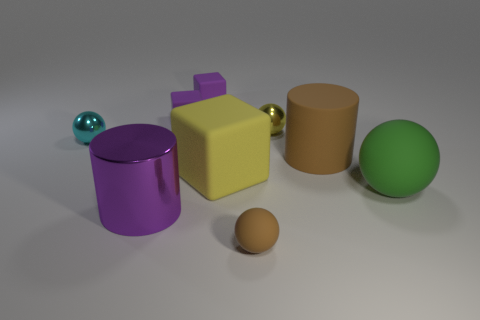Subtract all small matte cubes. How many cubes are left? 1 Subtract all cyan balls. How many balls are left? 3 Subtract all cyan balls. How many purple cubes are left? 2 Add 1 large green metal spheres. How many objects exist? 10 Subtract 1 balls. How many balls are left? 3 Subtract all red spheres. Subtract all red blocks. How many spheres are left? 4 Subtract 0 gray balls. How many objects are left? 9 Subtract all cylinders. How many objects are left? 7 Subtract all small rubber things. Subtract all large purple cylinders. How many objects are left? 5 Add 7 small matte things. How many small matte things are left? 10 